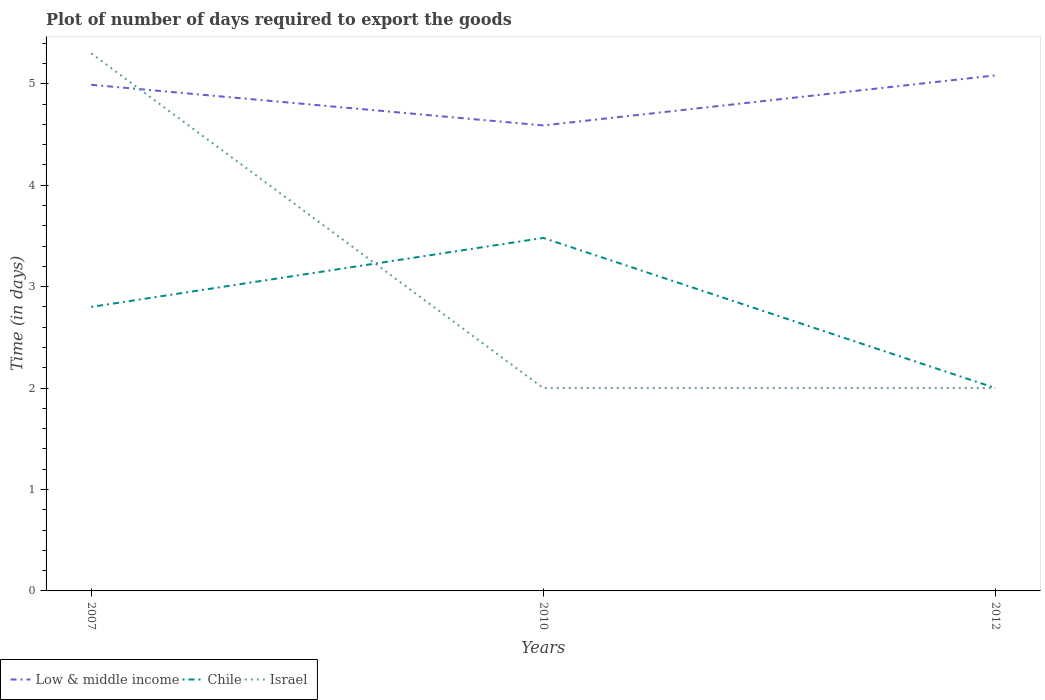Does the line corresponding to Israel intersect with the line corresponding to Chile?
Provide a succinct answer. Yes. Across all years, what is the maximum time required to export goods in Israel?
Provide a short and direct response. 2. What is the total time required to export goods in Low & middle income in the graph?
Give a very brief answer. -0.09. What is the difference between the highest and the second highest time required to export goods in Chile?
Your response must be concise. 1.48. Is the time required to export goods in Low & middle income strictly greater than the time required to export goods in Israel over the years?
Your answer should be very brief. No. What is the difference between two consecutive major ticks on the Y-axis?
Keep it short and to the point. 1. Where does the legend appear in the graph?
Provide a short and direct response. Bottom left. How many legend labels are there?
Your response must be concise. 3. What is the title of the graph?
Ensure brevity in your answer.  Plot of number of days required to export the goods. What is the label or title of the Y-axis?
Offer a very short reply. Time (in days). What is the Time (in days) in Low & middle income in 2007?
Your answer should be compact. 4.99. What is the Time (in days) in Chile in 2007?
Your response must be concise. 2.8. What is the Time (in days) in Low & middle income in 2010?
Keep it short and to the point. 4.59. What is the Time (in days) of Chile in 2010?
Offer a terse response. 3.48. What is the Time (in days) of Israel in 2010?
Your answer should be very brief. 2. What is the Time (in days) in Low & middle income in 2012?
Give a very brief answer. 5.08. What is the Time (in days) of Chile in 2012?
Provide a succinct answer. 2. What is the Time (in days) in Israel in 2012?
Provide a succinct answer. 2. Across all years, what is the maximum Time (in days) of Low & middle income?
Offer a very short reply. 5.08. Across all years, what is the maximum Time (in days) of Chile?
Your answer should be compact. 3.48. Across all years, what is the minimum Time (in days) of Low & middle income?
Provide a short and direct response. 4.59. Across all years, what is the minimum Time (in days) of Chile?
Your answer should be compact. 2. Across all years, what is the minimum Time (in days) in Israel?
Your response must be concise. 2. What is the total Time (in days) of Low & middle income in the graph?
Make the answer very short. 14.66. What is the total Time (in days) in Chile in the graph?
Give a very brief answer. 8.28. What is the total Time (in days) in Israel in the graph?
Ensure brevity in your answer.  9.3. What is the difference between the Time (in days) in Low & middle income in 2007 and that in 2010?
Keep it short and to the point. 0.4. What is the difference between the Time (in days) of Chile in 2007 and that in 2010?
Your answer should be compact. -0.68. What is the difference between the Time (in days) in Low & middle income in 2007 and that in 2012?
Offer a very short reply. -0.09. What is the difference between the Time (in days) in Low & middle income in 2010 and that in 2012?
Your answer should be compact. -0.49. What is the difference between the Time (in days) in Chile in 2010 and that in 2012?
Offer a terse response. 1.48. What is the difference between the Time (in days) of Israel in 2010 and that in 2012?
Provide a short and direct response. 0. What is the difference between the Time (in days) in Low & middle income in 2007 and the Time (in days) in Chile in 2010?
Your answer should be very brief. 1.51. What is the difference between the Time (in days) in Low & middle income in 2007 and the Time (in days) in Israel in 2010?
Keep it short and to the point. 2.99. What is the difference between the Time (in days) of Chile in 2007 and the Time (in days) of Israel in 2010?
Your answer should be compact. 0.8. What is the difference between the Time (in days) of Low & middle income in 2007 and the Time (in days) of Chile in 2012?
Provide a succinct answer. 2.99. What is the difference between the Time (in days) of Low & middle income in 2007 and the Time (in days) of Israel in 2012?
Offer a very short reply. 2.99. What is the difference between the Time (in days) in Chile in 2007 and the Time (in days) in Israel in 2012?
Give a very brief answer. 0.8. What is the difference between the Time (in days) in Low & middle income in 2010 and the Time (in days) in Chile in 2012?
Provide a succinct answer. 2.59. What is the difference between the Time (in days) of Low & middle income in 2010 and the Time (in days) of Israel in 2012?
Offer a terse response. 2.59. What is the difference between the Time (in days) of Chile in 2010 and the Time (in days) of Israel in 2012?
Keep it short and to the point. 1.48. What is the average Time (in days) in Low & middle income per year?
Your answer should be compact. 4.89. What is the average Time (in days) of Chile per year?
Ensure brevity in your answer.  2.76. What is the average Time (in days) in Israel per year?
Ensure brevity in your answer.  3.1. In the year 2007, what is the difference between the Time (in days) of Low & middle income and Time (in days) of Chile?
Your answer should be compact. 2.19. In the year 2007, what is the difference between the Time (in days) of Low & middle income and Time (in days) of Israel?
Offer a terse response. -0.31. In the year 2007, what is the difference between the Time (in days) in Chile and Time (in days) in Israel?
Your answer should be compact. -2.5. In the year 2010, what is the difference between the Time (in days) of Low & middle income and Time (in days) of Chile?
Offer a very short reply. 1.11. In the year 2010, what is the difference between the Time (in days) of Low & middle income and Time (in days) of Israel?
Make the answer very short. 2.59. In the year 2010, what is the difference between the Time (in days) of Chile and Time (in days) of Israel?
Make the answer very short. 1.48. In the year 2012, what is the difference between the Time (in days) in Low & middle income and Time (in days) in Chile?
Make the answer very short. 3.08. In the year 2012, what is the difference between the Time (in days) of Low & middle income and Time (in days) of Israel?
Offer a terse response. 3.08. What is the ratio of the Time (in days) of Low & middle income in 2007 to that in 2010?
Offer a very short reply. 1.09. What is the ratio of the Time (in days) in Chile in 2007 to that in 2010?
Give a very brief answer. 0.8. What is the ratio of the Time (in days) of Israel in 2007 to that in 2010?
Your answer should be very brief. 2.65. What is the ratio of the Time (in days) of Low & middle income in 2007 to that in 2012?
Offer a terse response. 0.98. What is the ratio of the Time (in days) in Chile in 2007 to that in 2012?
Ensure brevity in your answer.  1.4. What is the ratio of the Time (in days) of Israel in 2007 to that in 2012?
Your answer should be very brief. 2.65. What is the ratio of the Time (in days) in Low & middle income in 2010 to that in 2012?
Provide a succinct answer. 0.9. What is the ratio of the Time (in days) in Chile in 2010 to that in 2012?
Make the answer very short. 1.74. What is the difference between the highest and the second highest Time (in days) of Low & middle income?
Ensure brevity in your answer.  0.09. What is the difference between the highest and the second highest Time (in days) in Chile?
Offer a terse response. 0.68. What is the difference between the highest and the second highest Time (in days) in Israel?
Your response must be concise. 3.3. What is the difference between the highest and the lowest Time (in days) in Low & middle income?
Provide a succinct answer. 0.49. What is the difference between the highest and the lowest Time (in days) in Chile?
Give a very brief answer. 1.48. 